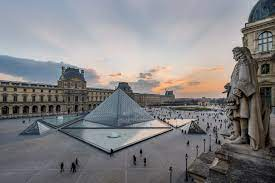Imagine if the glass pyramid were to host an otherworldly art exhibit. What might that look like? Envision the glass pyramid at the Louvre transformed into the epicenter of an otherworldly art exhibit, attracting not just international visitors, but beings from galaxies far away. The exhibit, titled 'Art Beyond Earth,' features holographic artworks created by renowned artists from diverse alien civilizations. Each piece showcases the unique aesthetic sensibilities and cultural narratives of different worlds, rendered in vibrant, ethereal forms that defy earthly physics. The pyramid itself is illuminated with bioluminescent materials, casting an otherworldly glow that changes colors based on the time of day and visitors' interactions. The reflective pool transforms into a shimmering portal, revealing glimpses of distant planets and cosmic phenomena. Visitors, adorned with special augmented reality glasses, can navigate the exhibit, experiencing art that transcends human comprehension, blending multi-sensory elements like interstellar sounds and scents carried across the universe. The courtyard buzzes with the excitement of these intergalactic cultural exchanges, where earthly and extraterrestrial art blend seamlessly, expanding the very definition of creativity. If you were to suggest a new architectural feature for the Louvre, what would it be and why? I would suggest the addition of a 'Sky Gallery,' a transparent, elevated walkway that circles the entire Louvre courtyard. Supported by sleek, modern pillars, the Sky Gallery would offer visitors a 360-degree panoramic view of the courtyard and the surrounding historic buildings. Made from state-of-the-art glass and carbon-fiber materials, this new feature would provide an immersive experience, as visitors walk above the bustling courtyard, feeling both connected to and apart from the activity below. Interactive plaques and digital displays along the walkway would provide historical insights and artistic details, creating an educational journey. Additionally, the Sky Gallery could serve as an exhibition space for temporary art installations and live performances, blending the museum's rich history with contemporary cultural expressions, and making the courtyard an even more dynamic and engaging space for visitors. 